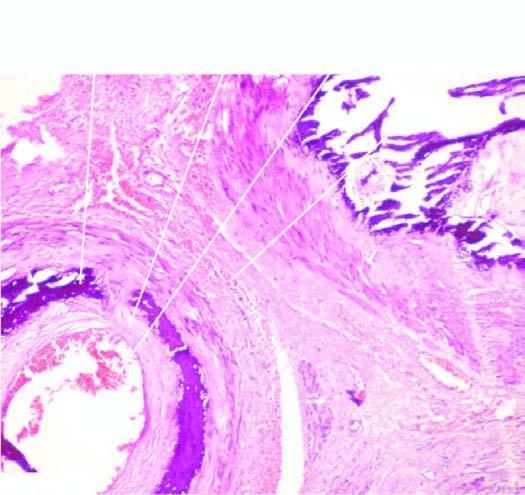s the cut surface calcification exclusively in the tunica media unassociated with any significant inflammation?
Answer the question using a single word or phrase. No 